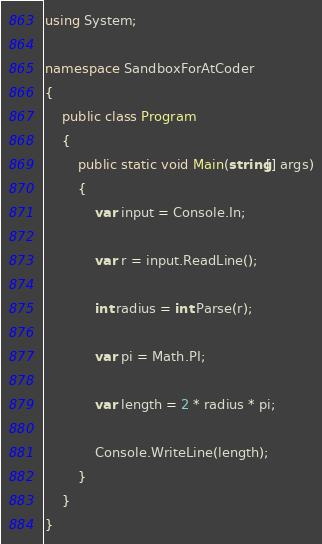<code> <loc_0><loc_0><loc_500><loc_500><_C#_>using System;

namespace SandboxForAtCoder
{
    public class Program
    {
        public static void Main(string[] args)
        {
            var input = Console.In;

            var r = input.ReadLine();

            int radius = int.Parse(r);

            var pi = Math.PI;

            var length = 2 * radius * pi;

            Console.WriteLine(length);
        }
    }
}
</code> 